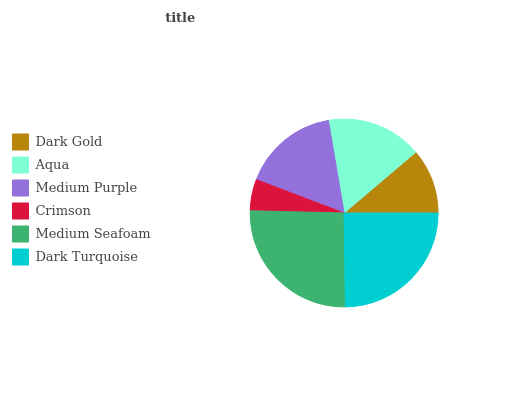Is Crimson the minimum?
Answer yes or no. Yes. Is Medium Seafoam the maximum?
Answer yes or no. Yes. Is Aqua the minimum?
Answer yes or no. No. Is Aqua the maximum?
Answer yes or no. No. Is Aqua greater than Dark Gold?
Answer yes or no. Yes. Is Dark Gold less than Aqua?
Answer yes or no. Yes. Is Dark Gold greater than Aqua?
Answer yes or no. No. Is Aqua less than Dark Gold?
Answer yes or no. No. Is Medium Purple the high median?
Answer yes or no. Yes. Is Aqua the low median?
Answer yes or no. Yes. Is Medium Seafoam the high median?
Answer yes or no. No. Is Medium Purple the low median?
Answer yes or no. No. 